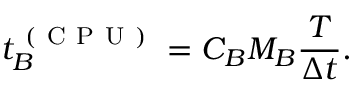<formula> <loc_0><loc_0><loc_500><loc_500>t _ { B } ^ { ( C P U ) } = C _ { B } M _ { B } \frac { T } { \Delta t } .</formula> 